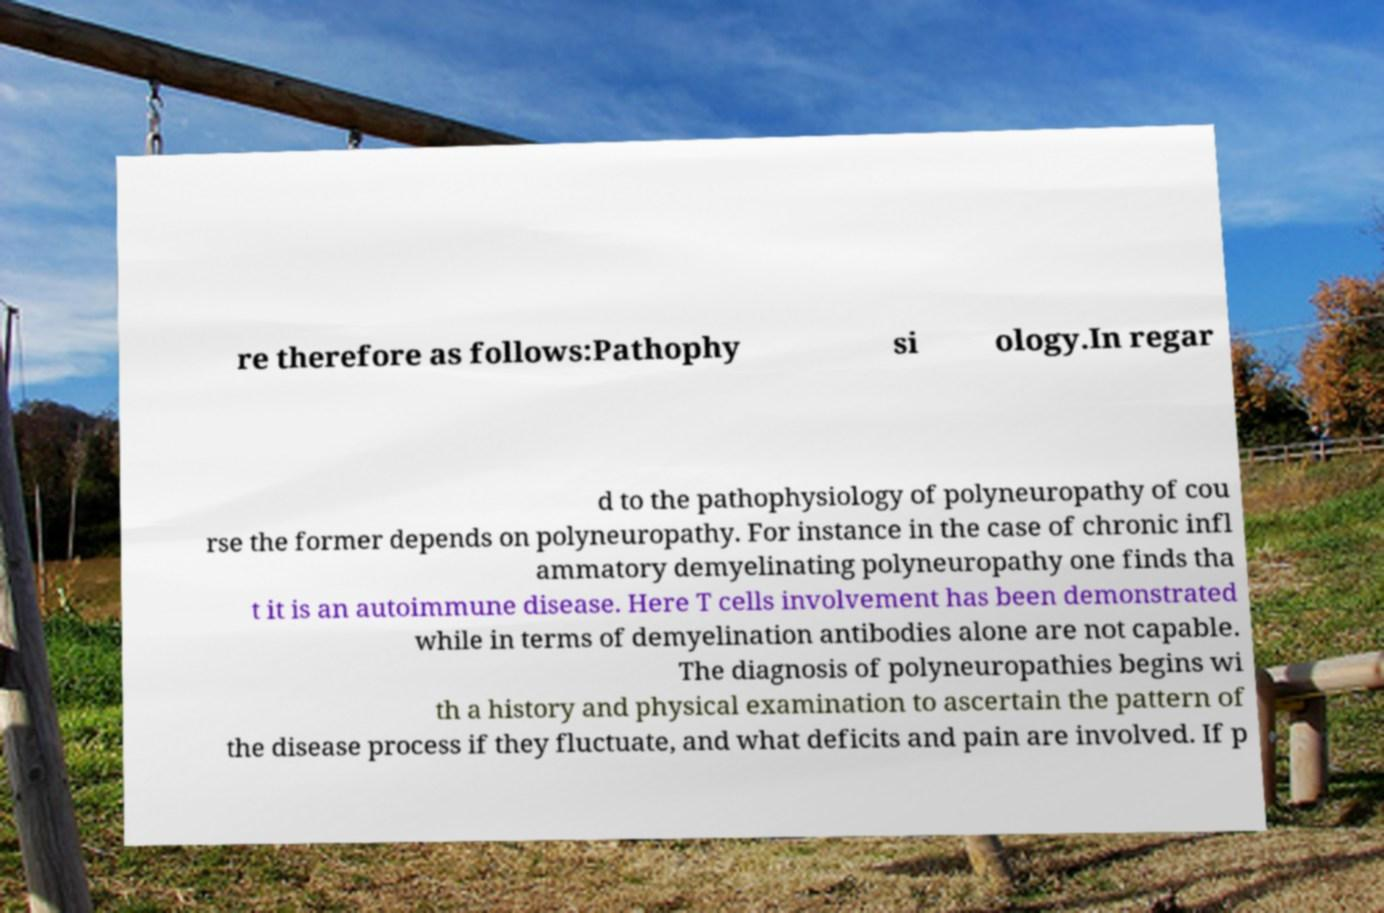Can you accurately transcribe the text from the provided image for me? re therefore as follows:Pathophy si ology.In regar d to the pathophysiology of polyneuropathy of cou rse the former depends on polyneuropathy. For instance in the case of chronic infl ammatory demyelinating polyneuropathy one finds tha t it is an autoimmune disease. Here T cells involvement has been demonstrated while in terms of demyelination antibodies alone are not capable. The diagnosis of polyneuropathies begins wi th a history and physical examination to ascertain the pattern of the disease process if they fluctuate, and what deficits and pain are involved. If p 